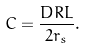<formula> <loc_0><loc_0><loc_500><loc_500>C = \frac { D R L } { 2 r _ { s } } .</formula> 